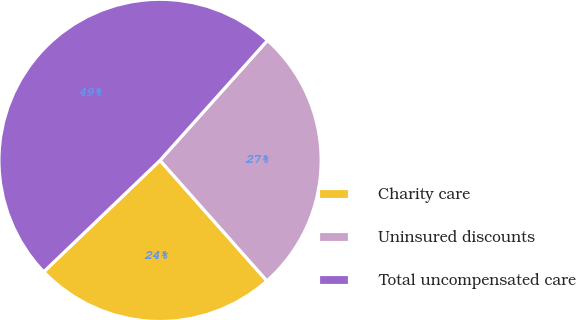Convert chart. <chart><loc_0><loc_0><loc_500><loc_500><pie_chart><fcel>Charity care<fcel>Uninsured discounts<fcel>Total uncompensated care<nl><fcel>24.39%<fcel>26.83%<fcel>48.78%<nl></chart> 